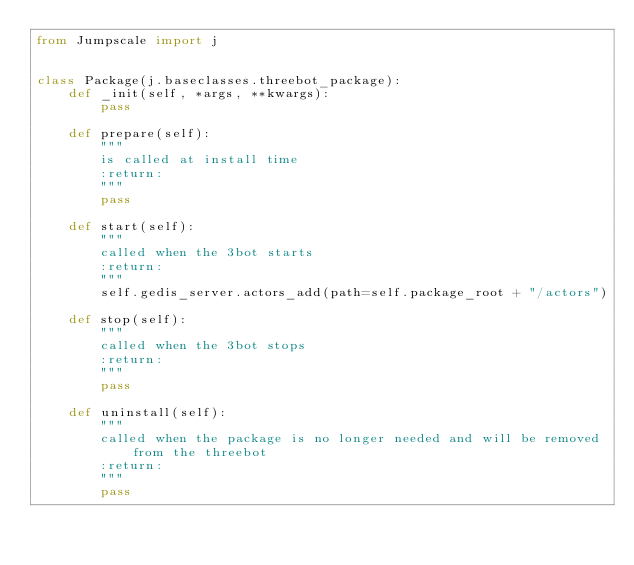Convert code to text. <code><loc_0><loc_0><loc_500><loc_500><_Python_>from Jumpscale import j


class Package(j.baseclasses.threebot_package):
    def _init(self, *args, **kwargs):
        pass

    def prepare(self):
        """
        is called at install time
        :return:
        """
        pass

    def start(self):
        """
        called when the 3bot starts
        :return:
        """
        self.gedis_server.actors_add(path=self.package_root + "/actors")

    def stop(self):
        """
        called when the 3bot stops
        :return:
        """
        pass

    def uninstall(self):
        """
        called when the package is no longer needed and will be removed from the threebot
        :return:
        """
        pass
</code> 